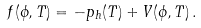Convert formula to latex. <formula><loc_0><loc_0><loc_500><loc_500>f ( \phi , T ) = - p _ { h } ( T ) + V ( \phi , T ) \, .</formula> 